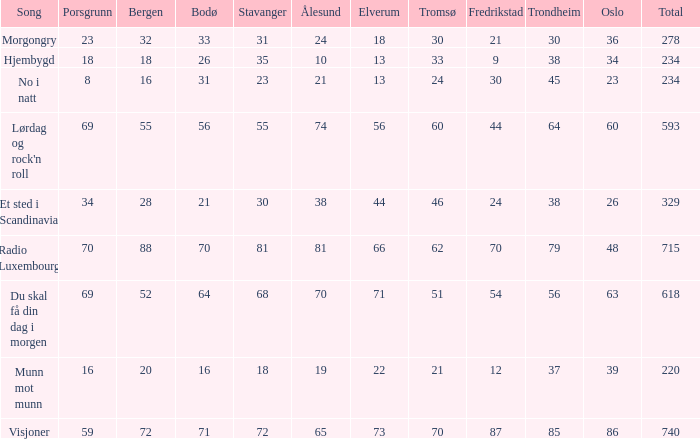Would you mind parsing the complete table? {'header': ['Song', 'Porsgrunn', 'Bergen', 'Bodø', 'Stavanger', 'Ålesund', 'Elverum', 'Tromsø', 'Fredrikstad', 'Trondheim', 'Oslo', 'Total'], 'rows': [['Morgongry', '23', '32', '33', '31', '24', '18', '30', '21', '30', '36', '278'], ['Hjembygd', '18', '18', '26', '35', '10', '13', '33', '9', '38', '34', '234'], ['No i natt', '8', '16', '31', '23', '21', '13', '24', '30', '45', '23', '234'], ["Lørdag og rock'n roll", '69', '55', '56', '55', '74', '56', '60', '44', '64', '60', '593'], ['Et sted i Scandinavia', '34', '28', '21', '30', '38', '44', '46', '24', '38', '26', '329'], ['Radio Luxembourg', '70', '88', '70', '81', '81', '66', '62', '70', '79', '48', '715'], ['Du skal få din dag i morgen', '69', '52', '64', '68', '70', '71', '51', '54', '56', '63', '618'], ['Munn mot munn', '16', '20', '16', '18', '19', '22', '21', '12', '37', '39', '220'], ['Visjoner', '59', '72', '71', '72', '65', '73', '70', '87', '85', '86', '740']]} When oslo is 48, what is stavanger? 81.0. 